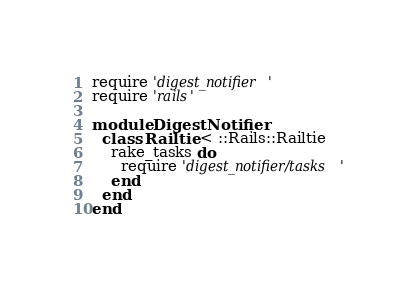Convert code to text. <code><loc_0><loc_0><loc_500><loc_500><_Ruby_>require 'digest_notifier'
require 'rails'

module DigestNotifier
  class Railtie < ::Rails::Railtie
    rake_tasks do
      require 'digest_notifier/tasks'
    end
  end
end
</code> 